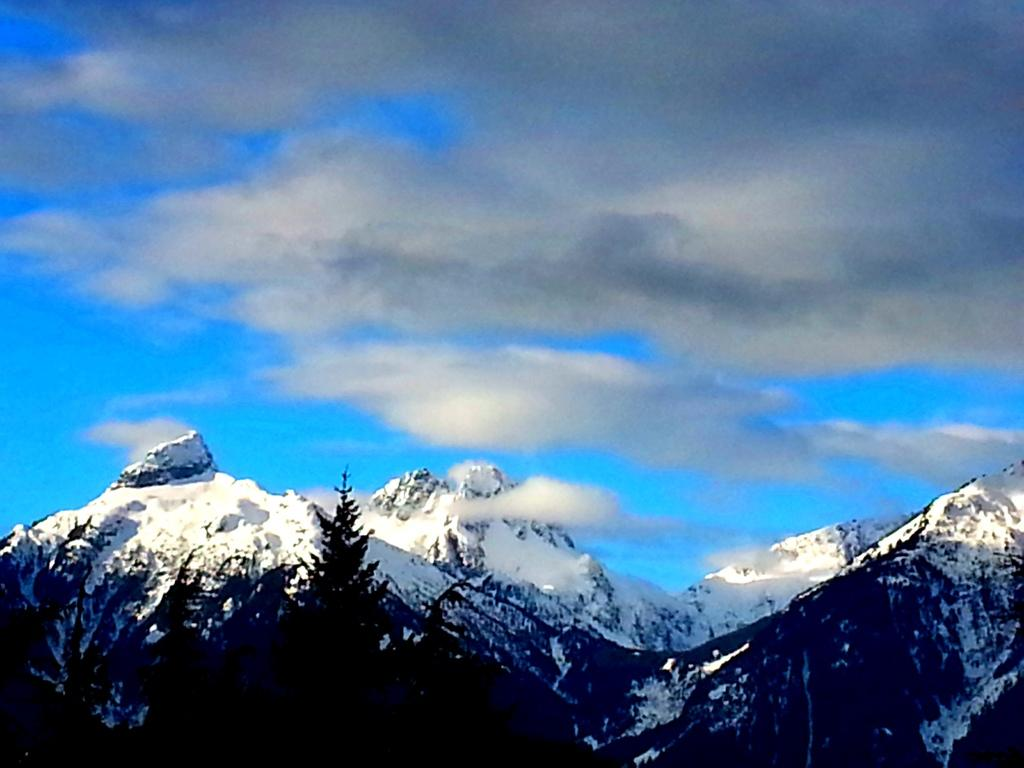What type of natural formation can be seen in the image? There are mountains in the image. How are the mountains arranged in the image? The mountains are depicted from left to right. What is the color of the sky in the image? The sky is blue in color. Are there any clouds visible in the sky? Yes, the sky is cloudy in the image. What type of doll is being transported by the army on a boat in the image? There is no doll, army, or boat present in the image; it only features mountains and a cloudy sky. 